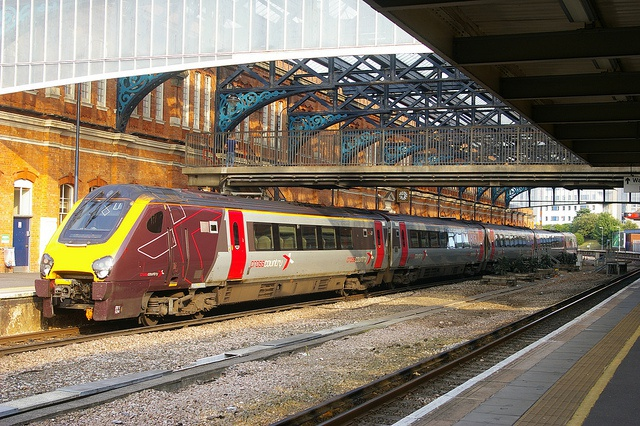Describe the objects in this image and their specific colors. I can see train in lightgray, black, gray, maroon, and brown tones and clock in lightgray, darkgray, gray, and maroon tones in this image. 